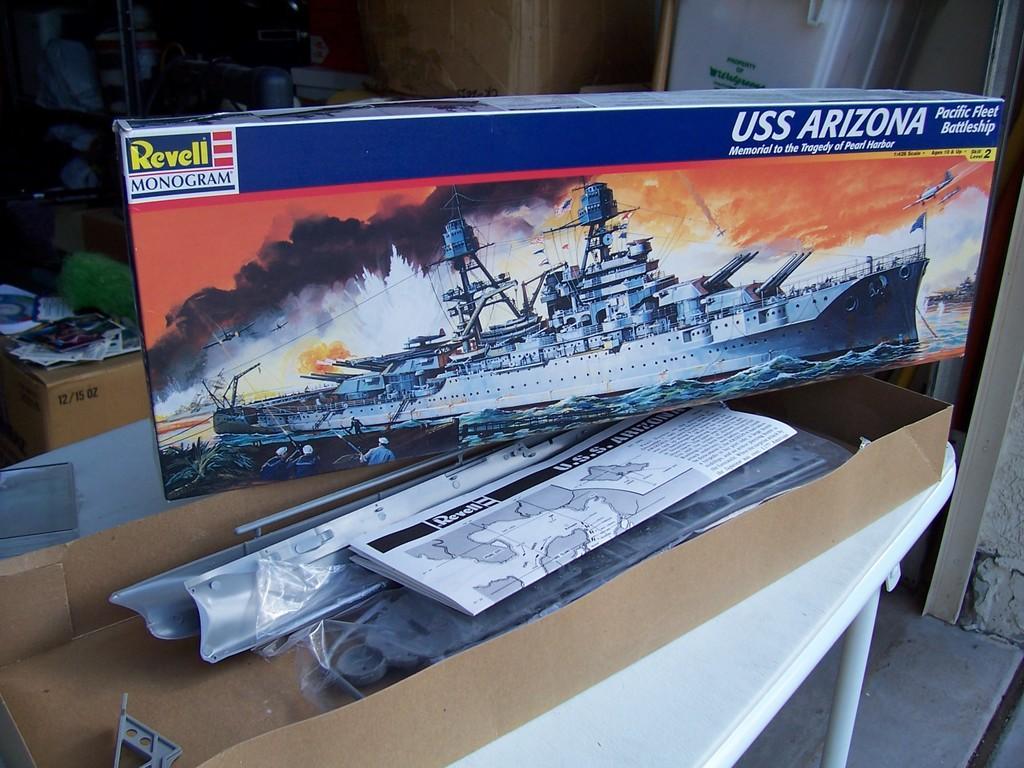How would you summarize this image in a sentence or two? In this picture I can see cardboard boxes, papers, there is a table, and in the background there are some objects. 